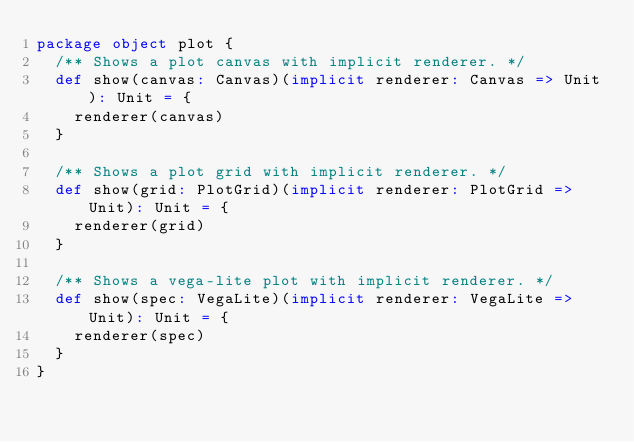Convert code to text. <code><loc_0><loc_0><loc_500><loc_500><_Scala_>package object plot {
  /** Shows a plot canvas with implicit renderer. */
  def show(canvas: Canvas)(implicit renderer: Canvas => Unit): Unit = {
    renderer(canvas)
  }

  /** Shows a plot grid with implicit renderer. */
  def show(grid: PlotGrid)(implicit renderer: PlotGrid => Unit): Unit = {
    renderer(grid)
  }

  /** Shows a vega-lite plot with implicit renderer. */
  def show(spec: VegaLite)(implicit renderer: VegaLite => Unit): Unit = {
    renderer(spec)
  }
}
</code> 